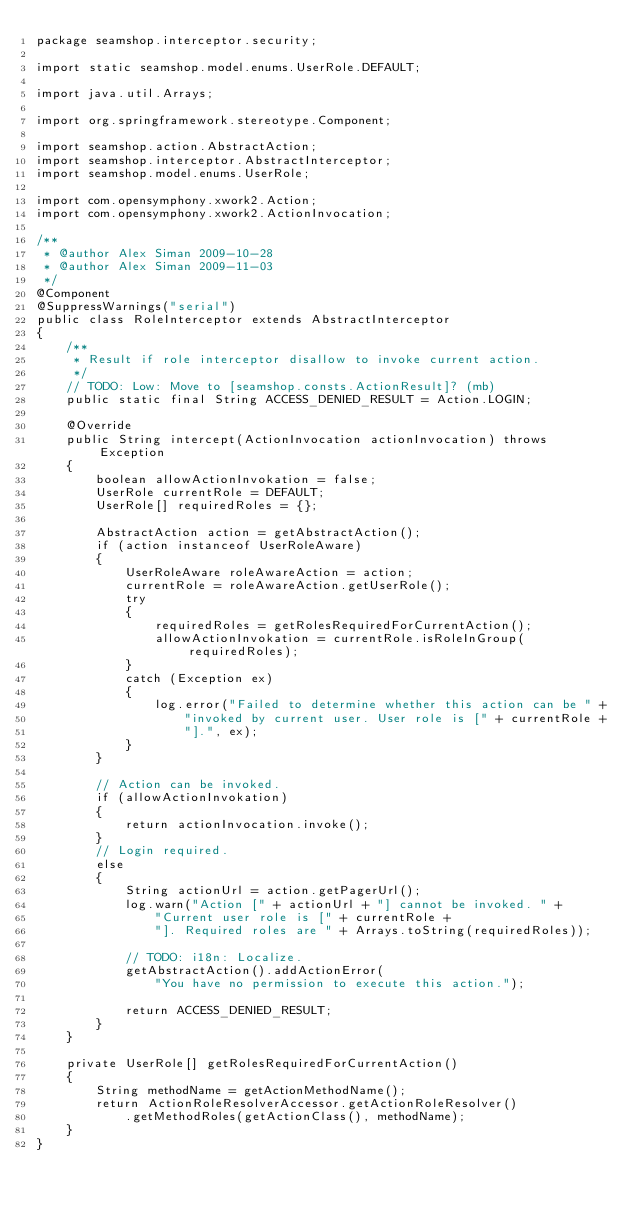<code> <loc_0><loc_0><loc_500><loc_500><_Java_>package seamshop.interceptor.security;

import static seamshop.model.enums.UserRole.DEFAULT;

import java.util.Arrays;

import org.springframework.stereotype.Component;

import seamshop.action.AbstractAction;
import seamshop.interceptor.AbstractInterceptor;
import seamshop.model.enums.UserRole;

import com.opensymphony.xwork2.Action;
import com.opensymphony.xwork2.ActionInvocation;

/**
 * @author Alex Siman 2009-10-28
 * @author Alex Siman 2009-11-03
 */
@Component
@SuppressWarnings("serial")
public class RoleInterceptor extends AbstractInterceptor
{
	/**
	 * Result if role interceptor disallow to invoke current action.
	 */
	// TODO: Low: Move to [seamshop.consts.ActionResult]? (mb)
	public static final String ACCESS_DENIED_RESULT = Action.LOGIN;

	@Override
	public String intercept(ActionInvocation actionInvocation) throws Exception
	{
		boolean allowActionInvokation = false;
		UserRole currentRole = DEFAULT;
		UserRole[] requiredRoles = {};

		AbstractAction action = getAbstractAction();
		if (action instanceof UserRoleAware)
		{
			UserRoleAware roleAwareAction = action;
			currentRole = roleAwareAction.getUserRole();
			try
			{
				requiredRoles = getRolesRequiredForCurrentAction();
				allowActionInvokation = currentRole.isRoleInGroup(requiredRoles);
			}
			catch (Exception ex)
			{
				log.error("Failed to determine whether this action can be " +
					"invoked by current user. User role is [" + currentRole +
					"].", ex);
			}
		}

		// Action can be invoked.
		if (allowActionInvokation)
		{
			return actionInvocation.invoke();
		}
		// Login required.
		else
		{
			String actionUrl = action.getPagerUrl();
			log.warn("Action [" + actionUrl + "] cannot be invoked. " +
				"Current user role is [" + currentRole +
				"]. Required roles are " + Arrays.toString(requiredRoles));

			// TODO: i18n: Localize.
			getAbstractAction().addActionError(
				"You have no permission to execute this action.");

			return ACCESS_DENIED_RESULT;
		}
	}

	private UserRole[] getRolesRequiredForCurrentAction()
	{
		String methodName = getActionMethodName();
		return ActionRoleResolverAccessor.getActionRoleResolver()
			.getMethodRoles(getActionClass(), methodName);
	}
}
</code> 